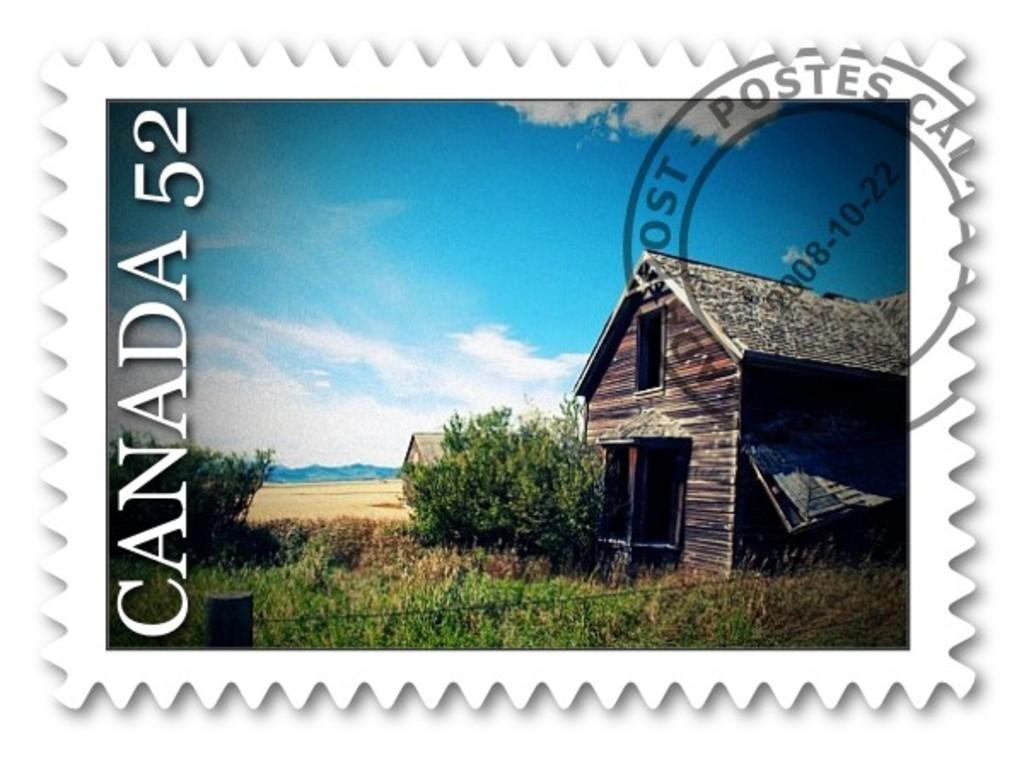What is the main subject of the image? The main subject of the image is a postage stamp. What type of pets are shown on the postage stamp? There are no pets shown on the postage stamp; it is a single object without any additional elements. 